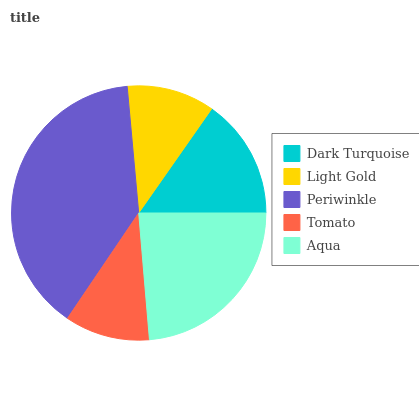Is Tomato the minimum?
Answer yes or no. Yes. Is Periwinkle the maximum?
Answer yes or no. Yes. Is Light Gold the minimum?
Answer yes or no. No. Is Light Gold the maximum?
Answer yes or no. No. Is Dark Turquoise greater than Light Gold?
Answer yes or no. Yes. Is Light Gold less than Dark Turquoise?
Answer yes or no. Yes. Is Light Gold greater than Dark Turquoise?
Answer yes or no. No. Is Dark Turquoise less than Light Gold?
Answer yes or no. No. Is Dark Turquoise the high median?
Answer yes or no. Yes. Is Dark Turquoise the low median?
Answer yes or no. Yes. Is Aqua the high median?
Answer yes or no. No. Is Tomato the low median?
Answer yes or no. No. 